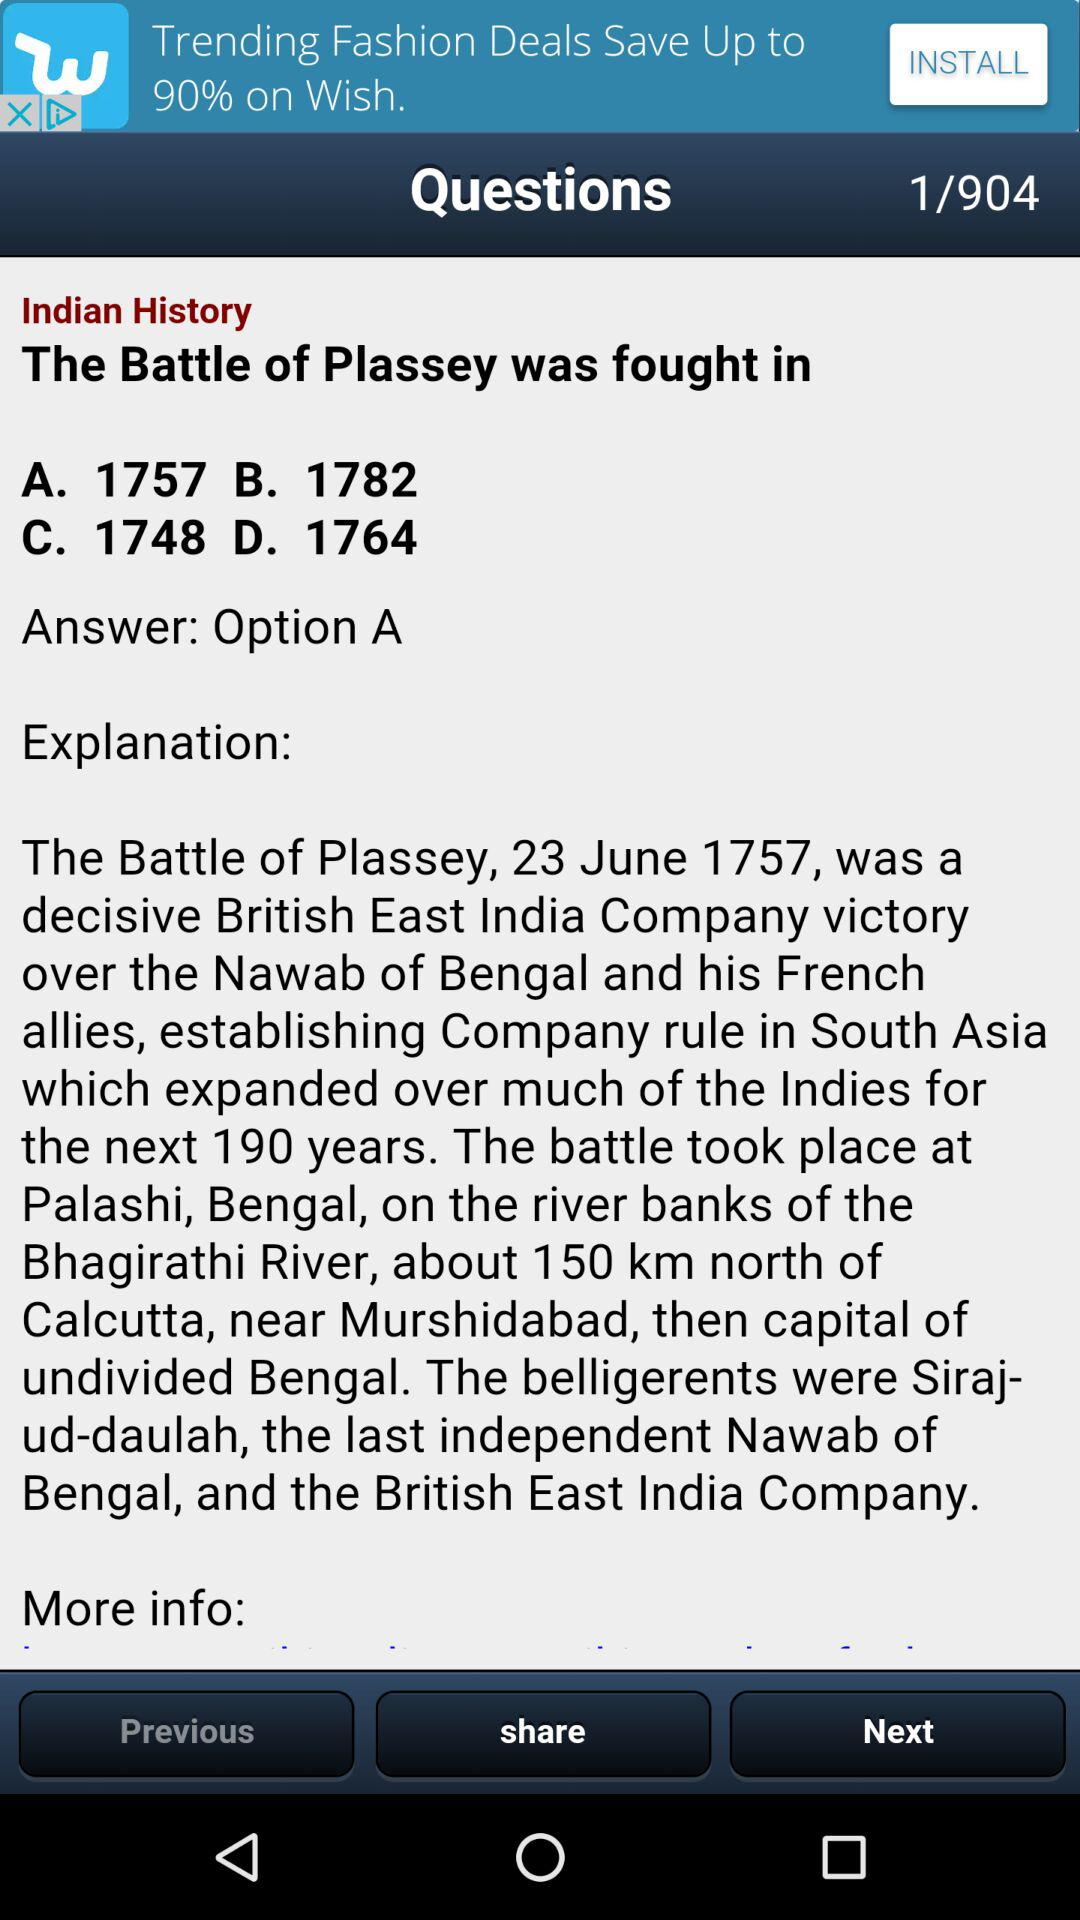How many questions are there? There are 904 questions. 